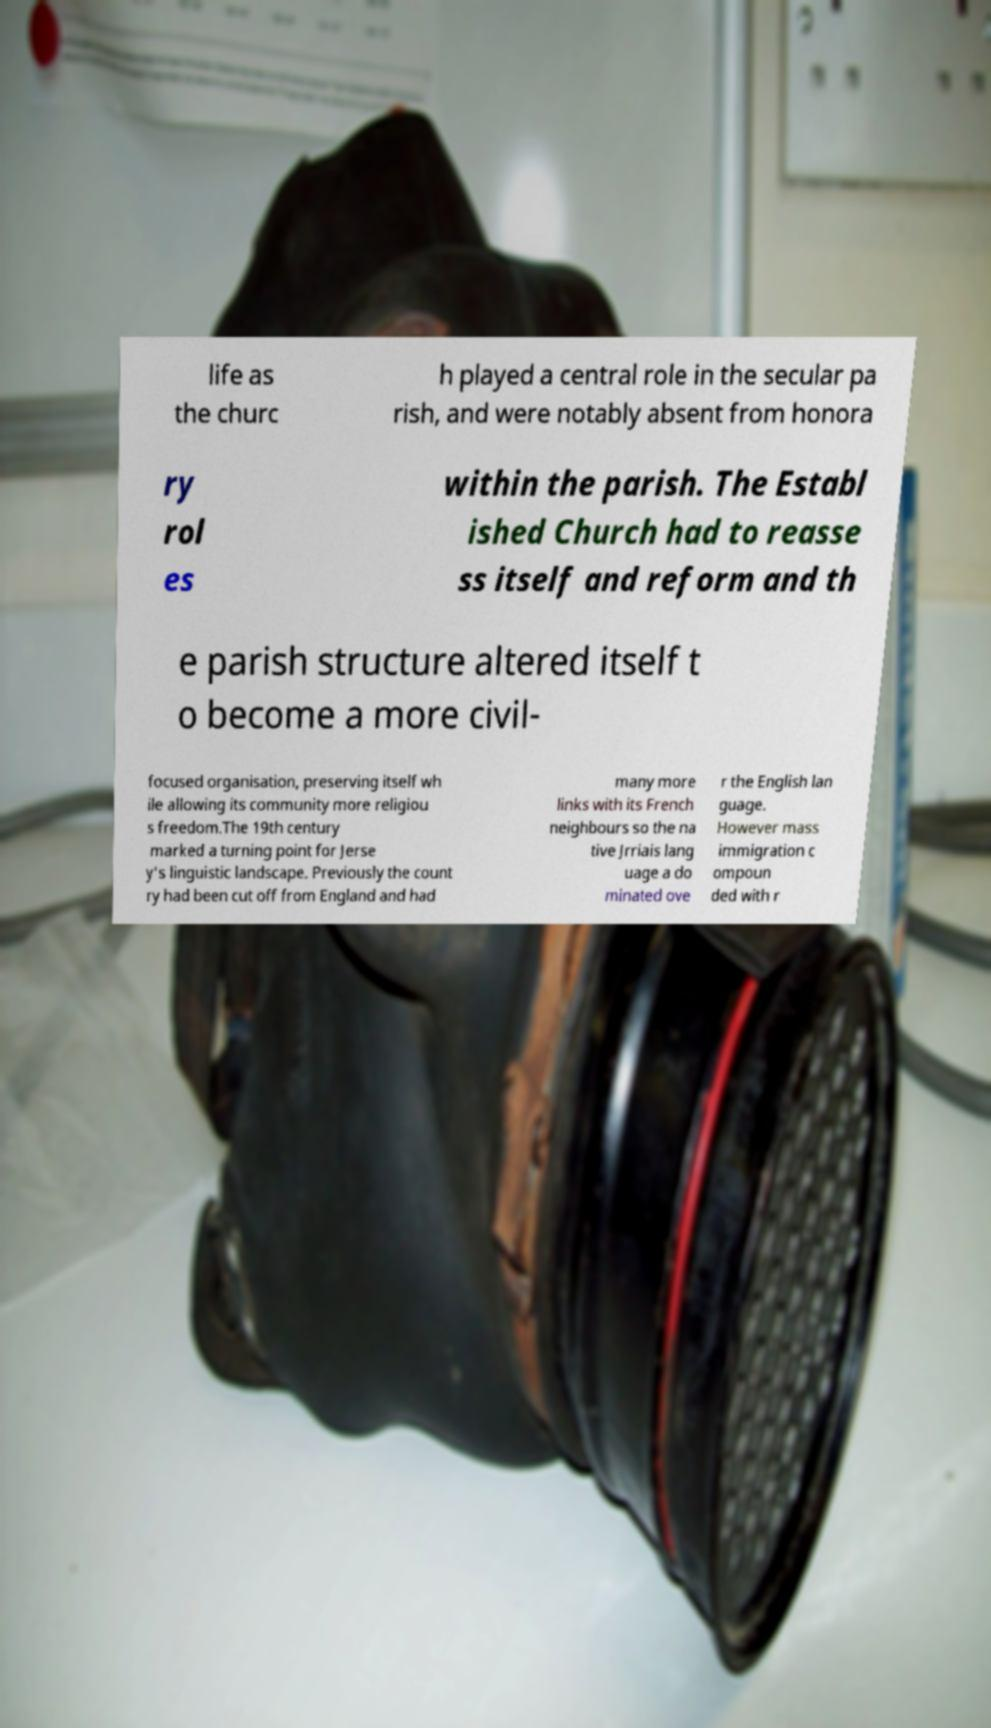What messages or text are displayed in this image? I need them in a readable, typed format. life as the churc h played a central role in the secular pa rish, and were notably absent from honora ry rol es within the parish. The Establ ished Church had to reasse ss itself and reform and th e parish structure altered itself t o become a more civil- focused organisation, preserving itself wh ile allowing its community more religiou s freedom.The 19th century marked a turning point for Jerse y's linguistic landscape. Previously the count ry had been cut off from England and had many more links with its French neighbours so the na tive Jrriais lang uage a do minated ove r the English lan guage. However mass immigration c ompoun ded with r 